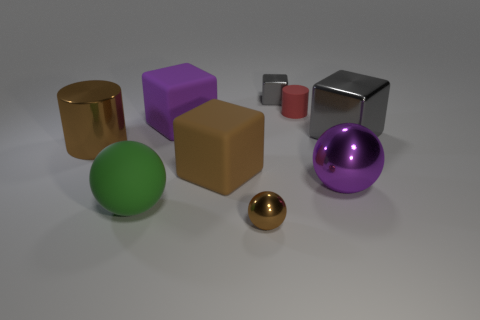Are there any patterns in how the objects are arranged? The objects seem to be randomly placed without any specific pattern; their sizes, colors, and placements do not follow a discernible order. Can you describe the lighting in this image? The lighting in the image appears to be soft and diffused, coming from above and casting gentle shadows directly beneath the objects. 